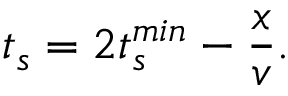<formula> <loc_0><loc_0><loc_500><loc_500>t _ { s } = 2 t _ { s } ^ { \min } - \frac { x } { v } .</formula> 